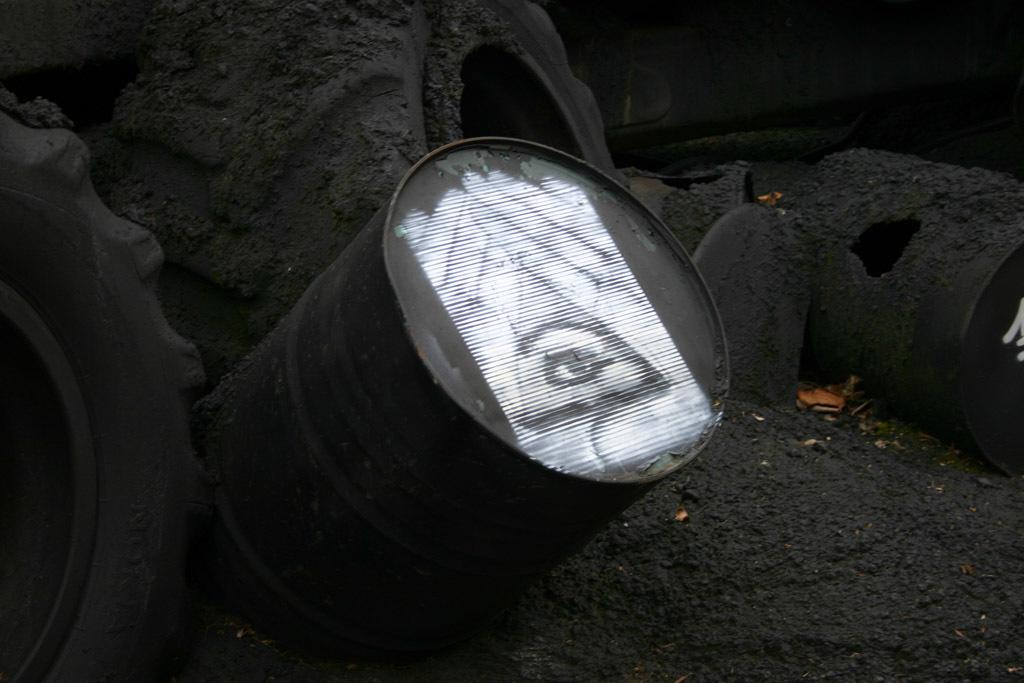What musical instruments are present in the image? There are drums in the image. What other objects can be seen in the image? There are tyres in the image. Can you tell me how many requests are being made in the image? There are no requests present in the image; it features drums and tyres. What type of creature can be seen interacting with the drums in the image? There is no creature present in the image; it only features drums and tyres. 